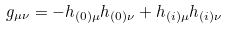Convert formula to latex. <formula><loc_0><loc_0><loc_500><loc_500>g _ { \mu \nu } = - h _ { ( 0 ) \mu } h _ { ( 0 ) \nu } + h _ { ( i ) \mu } h _ { ( i ) \nu }</formula> 